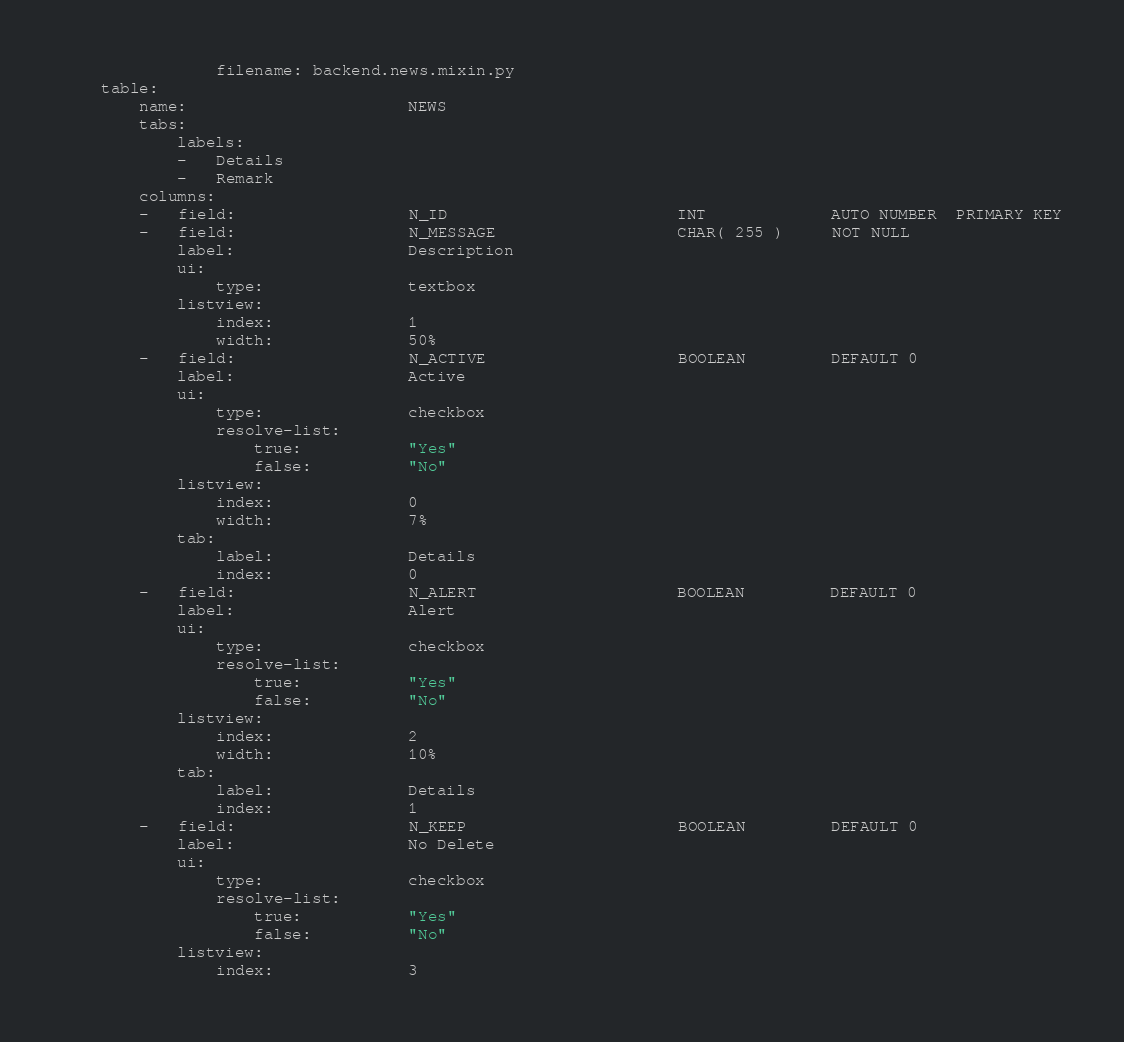Convert code to text. <code><loc_0><loc_0><loc_500><loc_500><_YAML_>                filename: backend.news.mixin.py
    table:
        name:                       NEWS
        tabs:
            labels:
            -   Details
            -   Remark
        columns:
        -   field:                  N_ID                        INT             AUTO NUMBER  PRIMARY KEY
        -   field:                  N_MESSAGE                   CHAR( 255 )     NOT NULL
            label:                  Description
            ui:
                type:               textbox
            listview:
                index:              1
                width:              50%
        -   field:                  N_ACTIVE                    BOOLEAN         DEFAULT 0
            label:                  Active
            ui:
                type:               checkbox
                resolve-list:
                    true:           "Yes"
                    false:          "No"
            listview:
                index:              0
                width:              7%
            tab:
                label:              Details
                index:              0
        -   field:                  N_ALERT                     BOOLEAN         DEFAULT 0
            label:                  Alert
            ui:
                type:               checkbox
                resolve-list:
                    true:           "Yes"
                    false:          "No"
            listview:
                index:              2
                width:              10%
            tab:
                label:              Details
                index:              1
        -   field:                  N_KEEP                      BOOLEAN         DEFAULT 0
            label:                  No Delete
            ui:
                type:               checkbox
                resolve-list:
                    true:           "Yes"
                    false:          "No"
            listview:
                index:              3</code> 